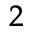<formula> <loc_0><loc_0><loc_500><loc_500>^ { 2 }</formula> 